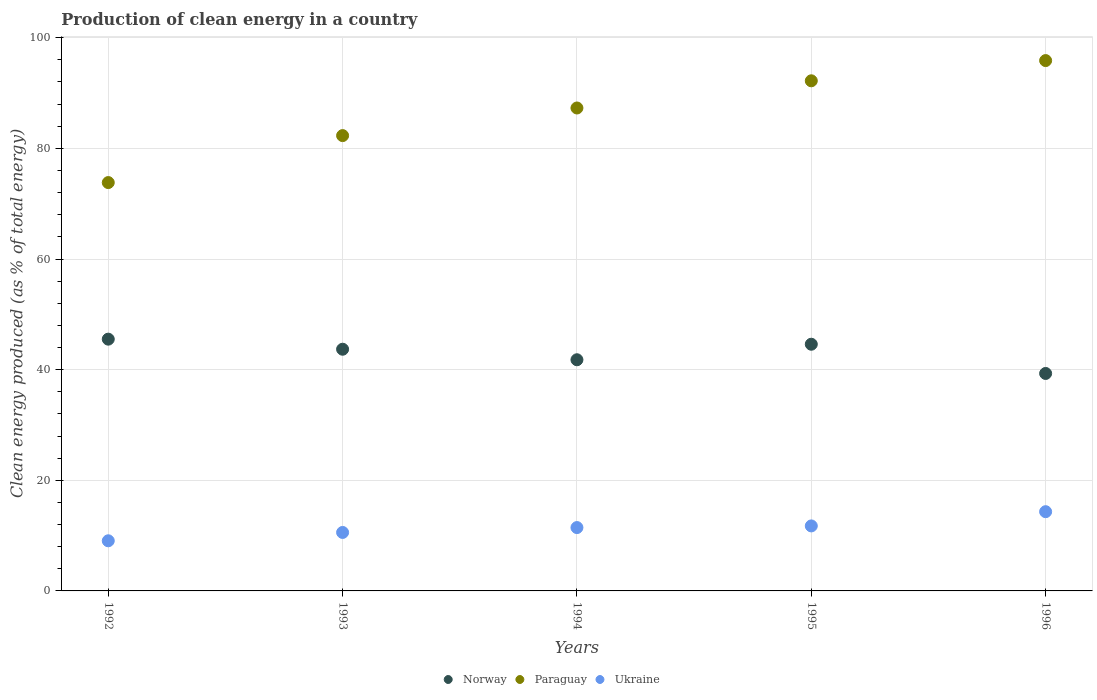What is the percentage of clean energy produced in Norway in 1994?
Give a very brief answer. 41.79. Across all years, what is the maximum percentage of clean energy produced in Paraguay?
Ensure brevity in your answer.  95.87. Across all years, what is the minimum percentage of clean energy produced in Paraguay?
Make the answer very short. 73.82. In which year was the percentage of clean energy produced in Norway minimum?
Provide a short and direct response. 1996. What is the total percentage of clean energy produced in Norway in the graph?
Your response must be concise. 214.89. What is the difference between the percentage of clean energy produced in Ukraine in 1993 and that in 1996?
Your answer should be very brief. -3.75. What is the difference between the percentage of clean energy produced in Paraguay in 1993 and the percentage of clean energy produced in Ukraine in 1994?
Give a very brief answer. 70.85. What is the average percentage of clean energy produced in Ukraine per year?
Make the answer very short. 11.43. In the year 1993, what is the difference between the percentage of clean energy produced in Paraguay and percentage of clean energy produced in Ukraine?
Provide a short and direct response. 71.74. In how many years, is the percentage of clean energy produced in Ukraine greater than 60 %?
Ensure brevity in your answer.  0. What is the ratio of the percentage of clean energy produced in Paraguay in 1993 to that in 1996?
Give a very brief answer. 0.86. What is the difference between the highest and the second highest percentage of clean energy produced in Norway?
Make the answer very short. 0.92. What is the difference between the highest and the lowest percentage of clean energy produced in Ukraine?
Give a very brief answer. 5.26. In how many years, is the percentage of clean energy produced in Norway greater than the average percentage of clean energy produced in Norway taken over all years?
Offer a very short reply. 3. Is the sum of the percentage of clean energy produced in Paraguay in 1994 and 1995 greater than the maximum percentage of clean energy produced in Ukraine across all years?
Ensure brevity in your answer.  Yes. Does the percentage of clean energy produced in Paraguay monotonically increase over the years?
Ensure brevity in your answer.  Yes. Is the percentage of clean energy produced in Ukraine strictly greater than the percentage of clean energy produced in Norway over the years?
Provide a succinct answer. No. How many dotlines are there?
Your answer should be compact. 3. How many years are there in the graph?
Keep it short and to the point. 5. What is the difference between two consecutive major ticks on the Y-axis?
Your answer should be compact. 20. Does the graph contain any zero values?
Your answer should be very brief. No. Where does the legend appear in the graph?
Offer a very short reply. Bottom center. How many legend labels are there?
Offer a very short reply. 3. What is the title of the graph?
Your response must be concise. Production of clean energy in a country. What is the label or title of the Y-axis?
Your answer should be very brief. Clean energy produced (as % of total energy). What is the Clean energy produced (as % of total energy) of Norway in 1992?
Provide a succinct answer. 45.51. What is the Clean energy produced (as % of total energy) in Paraguay in 1992?
Keep it short and to the point. 73.82. What is the Clean energy produced (as % of total energy) of Ukraine in 1992?
Your response must be concise. 9.06. What is the Clean energy produced (as % of total energy) in Norway in 1993?
Make the answer very short. 43.69. What is the Clean energy produced (as % of total energy) in Paraguay in 1993?
Keep it short and to the point. 82.31. What is the Clean energy produced (as % of total energy) of Ukraine in 1993?
Your answer should be compact. 10.57. What is the Clean energy produced (as % of total energy) of Norway in 1994?
Provide a succinct answer. 41.79. What is the Clean energy produced (as % of total energy) in Paraguay in 1994?
Provide a succinct answer. 87.3. What is the Clean energy produced (as % of total energy) in Ukraine in 1994?
Your answer should be compact. 11.45. What is the Clean energy produced (as % of total energy) of Norway in 1995?
Make the answer very short. 44.59. What is the Clean energy produced (as % of total energy) in Paraguay in 1995?
Ensure brevity in your answer.  92.21. What is the Clean energy produced (as % of total energy) of Ukraine in 1995?
Offer a very short reply. 11.75. What is the Clean energy produced (as % of total energy) in Norway in 1996?
Provide a short and direct response. 39.31. What is the Clean energy produced (as % of total energy) in Paraguay in 1996?
Your response must be concise. 95.87. What is the Clean energy produced (as % of total energy) of Ukraine in 1996?
Make the answer very short. 14.32. Across all years, what is the maximum Clean energy produced (as % of total energy) in Norway?
Make the answer very short. 45.51. Across all years, what is the maximum Clean energy produced (as % of total energy) in Paraguay?
Provide a succinct answer. 95.87. Across all years, what is the maximum Clean energy produced (as % of total energy) in Ukraine?
Your response must be concise. 14.32. Across all years, what is the minimum Clean energy produced (as % of total energy) of Norway?
Your response must be concise. 39.31. Across all years, what is the minimum Clean energy produced (as % of total energy) of Paraguay?
Make the answer very short. 73.82. Across all years, what is the minimum Clean energy produced (as % of total energy) of Ukraine?
Offer a terse response. 9.06. What is the total Clean energy produced (as % of total energy) of Norway in the graph?
Provide a succinct answer. 214.89. What is the total Clean energy produced (as % of total energy) in Paraguay in the graph?
Your answer should be very brief. 431.5. What is the total Clean energy produced (as % of total energy) in Ukraine in the graph?
Your response must be concise. 57.16. What is the difference between the Clean energy produced (as % of total energy) of Norway in 1992 and that in 1993?
Make the answer very short. 1.82. What is the difference between the Clean energy produced (as % of total energy) in Paraguay in 1992 and that in 1993?
Make the answer very short. -8.49. What is the difference between the Clean energy produced (as % of total energy) of Ukraine in 1992 and that in 1993?
Give a very brief answer. -1.51. What is the difference between the Clean energy produced (as % of total energy) of Norway in 1992 and that in 1994?
Offer a very short reply. 3.72. What is the difference between the Clean energy produced (as % of total energy) in Paraguay in 1992 and that in 1994?
Provide a short and direct response. -13.48. What is the difference between the Clean energy produced (as % of total energy) of Ukraine in 1992 and that in 1994?
Ensure brevity in your answer.  -2.39. What is the difference between the Clean energy produced (as % of total energy) in Norway in 1992 and that in 1995?
Offer a terse response. 0.92. What is the difference between the Clean energy produced (as % of total energy) of Paraguay in 1992 and that in 1995?
Offer a very short reply. -18.4. What is the difference between the Clean energy produced (as % of total energy) of Ukraine in 1992 and that in 1995?
Ensure brevity in your answer.  -2.69. What is the difference between the Clean energy produced (as % of total energy) in Norway in 1992 and that in 1996?
Your answer should be very brief. 6.2. What is the difference between the Clean energy produced (as % of total energy) in Paraguay in 1992 and that in 1996?
Keep it short and to the point. -22.05. What is the difference between the Clean energy produced (as % of total energy) in Ukraine in 1992 and that in 1996?
Provide a short and direct response. -5.26. What is the difference between the Clean energy produced (as % of total energy) of Norway in 1993 and that in 1994?
Provide a succinct answer. 1.9. What is the difference between the Clean energy produced (as % of total energy) of Paraguay in 1993 and that in 1994?
Your response must be concise. -4.99. What is the difference between the Clean energy produced (as % of total energy) in Ukraine in 1993 and that in 1994?
Your response must be concise. -0.88. What is the difference between the Clean energy produced (as % of total energy) in Norway in 1993 and that in 1995?
Your response must be concise. -0.9. What is the difference between the Clean energy produced (as % of total energy) of Paraguay in 1993 and that in 1995?
Provide a short and direct response. -9.91. What is the difference between the Clean energy produced (as % of total energy) of Ukraine in 1993 and that in 1995?
Ensure brevity in your answer.  -1.18. What is the difference between the Clean energy produced (as % of total energy) of Norway in 1993 and that in 1996?
Provide a short and direct response. 4.38. What is the difference between the Clean energy produced (as % of total energy) in Paraguay in 1993 and that in 1996?
Keep it short and to the point. -13.56. What is the difference between the Clean energy produced (as % of total energy) of Ukraine in 1993 and that in 1996?
Ensure brevity in your answer.  -3.75. What is the difference between the Clean energy produced (as % of total energy) of Norway in 1994 and that in 1995?
Ensure brevity in your answer.  -2.81. What is the difference between the Clean energy produced (as % of total energy) of Paraguay in 1994 and that in 1995?
Offer a terse response. -4.91. What is the difference between the Clean energy produced (as % of total energy) of Ukraine in 1994 and that in 1995?
Offer a very short reply. -0.3. What is the difference between the Clean energy produced (as % of total energy) in Norway in 1994 and that in 1996?
Your answer should be very brief. 2.48. What is the difference between the Clean energy produced (as % of total energy) in Paraguay in 1994 and that in 1996?
Ensure brevity in your answer.  -8.57. What is the difference between the Clean energy produced (as % of total energy) of Ukraine in 1994 and that in 1996?
Provide a succinct answer. -2.87. What is the difference between the Clean energy produced (as % of total energy) of Norway in 1995 and that in 1996?
Your answer should be very brief. 5.28. What is the difference between the Clean energy produced (as % of total energy) in Paraguay in 1995 and that in 1996?
Provide a short and direct response. -3.65. What is the difference between the Clean energy produced (as % of total energy) of Ukraine in 1995 and that in 1996?
Your answer should be compact. -2.57. What is the difference between the Clean energy produced (as % of total energy) in Norway in 1992 and the Clean energy produced (as % of total energy) in Paraguay in 1993?
Offer a terse response. -36.8. What is the difference between the Clean energy produced (as % of total energy) in Norway in 1992 and the Clean energy produced (as % of total energy) in Ukraine in 1993?
Give a very brief answer. 34.94. What is the difference between the Clean energy produced (as % of total energy) of Paraguay in 1992 and the Clean energy produced (as % of total energy) of Ukraine in 1993?
Offer a very short reply. 63.25. What is the difference between the Clean energy produced (as % of total energy) of Norway in 1992 and the Clean energy produced (as % of total energy) of Paraguay in 1994?
Ensure brevity in your answer.  -41.79. What is the difference between the Clean energy produced (as % of total energy) in Norway in 1992 and the Clean energy produced (as % of total energy) in Ukraine in 1994?
Offer a very short reply. 34.06. What is the difference between the Clean energy produced (as % of total energy) in Paraguay in 1992 and the Clean energy produced (as % of total energy) in Ukraine in 1994?
Your response must be concise. 62.36. What is the difference between the Clean energy produced (as % of total energy) of Norway in 1992 and the Clean energy produced (as % of total energy) of Paraguay in 1995?
Keep it short and to the point. -46.7. What is the difference between the Clean energy produced (as % of total energy) in Norway in 1992 and the Clean energy produced (as % of total energy) in Ukraine in 1995?
Offer a terse response. 33.76. What is the difference between the Clean energy produced (as % of total energy) of Paraguay in 1992 and the Clean energy produced (as % of total energy) of Ukraine in 1995?
Provide a short and direct response. 62.07. What is the difference between the Clean energy produced (as % of total energy) of Norway in 1992 and the Clean energy produced (as % of total energy) of Paraguay in 1996?
Offer a terse response. -50.36. What is the difference between the Clean energy produced (as % of total energy) of Norway in 1992 and the Clean energy produced (as % of total energy) of Ukraine in 1996?
Keep it short and to the point. 31.19. What is the difference between the Clean energy produced (as % of total energy) of Paraguay in 1992 and the Clean energy produced (as % of total energy) of Ukraine in 1996?
Keep it short and to the point. 59.49. What is the difference between the Clean energy produced (as % of total energy) of Norway in 1993 and the Clean energy produced (as % of total energy) of Paraguay in 1994?
Provide a short and direct response. -43.61. What is the difference between the Clean energy produced (as % of total energy) in Norway in 1993 and the Clean energy produced (as % of total energy) in Ukraine in 1994?
Offer a terse response. 32.24. What is the difference between the Clean energy produced (as % of total energy) of Paraguay in 1993 and the Clean energy produced (as % of total energy) of Ukraine in 1994?
Ensure brevity in your answer.  70.85. What is the difference between the Clean energy produced (as % of total energy) in Norway in 1993 and the Clean energy produced (as % of total energy) in Paraguay in 1995?
Your response must be concise. -48.52. What is the difference between the Clean energy produced (as % of total energy) in Norway in 1993 and the Clean energy produced (as % of total energy) in Ukraine in 1995?
Your answer should be very brief. 31.94. What is the difference between the Clean energy produced (as % of total energy) in Paraguay in 1993 and the Clean energy produced (as % of total energy) in Ukraine in 1995?
Give a very brief answer. 70.56. What is the difference between the Clean energy produced (as % of total energy) in Norway in 1993 and the Clean energy produced (as % of total energy) in Paraguay in 1996?
Your answer should be compact. -52.18. What is the difference between the Clean energy produced (as % of total energy) of Norway in 1993 and the Clean energy produced (as % of total energy) of Ukraine in 1996?
Provide a succinct answer. 29.37. What is the difference between the Clean energy produced (as % of total energy) in Paraguay in 1993 and the Clean energy produced (as % of total energy) in Ukraine in 1996?
Your response must be concise. 67.98. What is the difference between the Clean energy produced (as % of total energy) of Norway in 1994 and the Clean energy produced (as % of total energy) of Paraguay in 1995?
Offer a very short reply. -50.43. What is the difference between the Clean energy produced (as % of total energy) in Norway in 1994 and the Clean energy produced (as % of total energy) in Ukraine in 1995?
Provide a succinct answer. 30.04. What is the difference between the Clean energy produced (as % of total energy) of Paraguay in 1994 and the Clean energy produced (as % of total energy) of Ukraine in 1995?
Your answer should be compact. 75.55. What is the difference between the Clean energy produced (as % of total energy) of Norway in 1994 and the Clean energy produced (as % of total energy) of Paraguay in 1996?
Your answer should be very brief. -54.08. What is the difference between the Clean energy produced (as % of total energy) of Norway in 1994 and the Clean energy produced (as % of total energy) of Ukraine in 1996?
Provide a succinct answer. 27.46. What is the difference between the Clean energy produced (as % of total energy) in Paraguay in 1994 and the Clean energy produced (as % of total energy) in Ukraine in 1996?
Offer a very short reply. 72.98. What is the difference between the Clean energy produced (as % of total energy) of Norway in 1995 and the Clean energy produced (as % of total energy) of Paraguay in 1996?
Keep it short and to the point. -51.27. What is the difference between the Clean energy produced (as % of total energy) of Norway in 1995 and the Clean energy produced (as % of total energy) of Ukraine in 1996?
Your answer should be very brief. 30.27. What is the difference between the Clean energy produced (as % of total energy) of Paraguay in 1995 and the Clean energy produced (as % of total energy) of Ukraine in 1996?
Give a very brief answer. 77.89. What is the average Clean energy produced (as % of total energy) of Norway per year?
Offer a very short reply. 42.98. What is the average Clean energy produced (as % of total energy) of Paraguay per year?
Make the answer very short. 86.3. What is the average Clean energy produced (as % of total energy) of Ukraine per year?
Make the answer very short. 11.43. In the year 1992, what is the difference between the Clean energy produced (as % of total energy) of Norway and Clean energy produced (as % of total energy) of Paraguay?
Ensure brevity in your answer.  -28.31. In the year 1992, what is the difference between the Clean energy produced (as % of total energy) in Norway and Clean energy produced (as % of total energy) in Ukraine?
Give a very brief answer. 36.45. In the year 1992, what is the difference between the Clean energy produced (as % of total energy) in Paraguay and Clean energy produced (as % of total energy) in Ukraine?
Your response must be concise. 64.75. In the year 1993, what is the difference between the Clean energy produced (as % of total energy) of Norway and Clean energy produced (as % of total energy) of Paraguay?
Your answer should be very brief. -38.62. In the year 1993, what is the difference between the Clean energy produced (as % of total energy) of Norway and Clean energy produced (as % of total energy) of Ukraine?
Provide a short and direct response. 33.12. In the year 1993, what is the difference between the Clean energy produced (as % of total energy) of Paraguay and Clean energy produced (as % of total energy) of Ukraine?
Give a very brief answer. 71.74. In the year 1994, what is the difference between the Clean energy produced (as % of total energy) of Norway and Clean energy produced (as % of total energy) of Paraguay?
Offer a very short reply. -45.51. In the year 1994, what is the difference between the Clean energy produced (as % of total energy) of Norway and Clean energy produced (as % of total energy) of Ukraine?
Your answer should be very brief. 30.34. In the year 1994, what is the difference between the Clean energy produced (as % of total energy) of Paraguay and Clean energy produced (as % of total energy) of Ukraine?
Make the answer very short. 75.85. In the year 1995, what is the difference between the Clean energy produced (as % of total energy) of Norway and Clean energy produced (as % of total energy) of Paraguay?
Ensure brevity in your answer.  -47.62. In the year 1995, what is the difference between the Clean energy produced (as % of total energy) of Norway and Clean energy produced (as % of total energy) of Ukraine?
Your answer should be compact. 32.84. In the year 1995, what is the difference between the Clean energy produced (as % of total energy) of Paraguay and Clean energy produced (as % of total energy) of Ukraine?
Your response must be concise. 80.46. In the year 1996, what is the difference between the Clean energy produced (as % of total energy) of Norway and Clean energy produced (as % of total energy) of Paraguay?
Offer a very short reply. -56.56. In the year 1996, what is the difference between the Clean energy produced (as % of total energy) of Norway and Clean energy produced (as % of total energy) of Ukraine?
Provide a short and direct response. 24.99. In the year 1996, what is the difference between the Clean energy produced (as % of total energy) in Paraguay and Clean energy produced (as % of total energy) in Ukraine?
Keep it short and to the point. 81.54. What is the ratio of the Clean energy produced (as % of total energy) of Norway in 1992 to that in 1993?
Give a very brief answer. 1.04. What is the ratio of the Clean energy produced (as % of total energy) of Paraguay in 1992 to that in 1993?
Your answer should be very brief. 0.9. What is the ratio of the Clean energy produced (as % of total energy) of Ukraine in 1992 to that in 1993?
Offer a very short reply. 0.86. What is the ratio of the Clean energy produced (as % of total energy) of Norway in 1992 to that in 1994?
Provide a short and direct response. 1.09. What is the ratio of the Clean energy produced (as % of total energy) in Paraguay in 1992 to that in 1994?
Make the answer very short. 0.85. What is the ratio of the Clean energy produced (as % of total energy) in Ukraine in 1992 to that in 1994?
Your response must be concise. 0.79. What is the ratio of the Clean energy produced (as % of total energy) of Norway in 1992 to that in 1995?
Provide a succinct answer. 1.02. What is the ratio of the Clean energy produced (as % of total energy) in Paraguay in 1992 to that in 1995?
Your response must be concise. 0.8. What is the ratio of the Clean energy produced (as % of total energy) of Ukraine in 1992 to that in 1995?
Your answer should be very brief. 0.77. What is the ratio of the Clean energy produced (as % of total energy) in Norway in 1992 to that in 1996?
Your answer should be very brief. 1.16. What is the ratio of the Clean energy produced (as % of total energy) in Paraguay in 1992 to that in 1996?
Your answer should be compact. 0.77. What is the ratio of the Clean energy produced (as % of total energy) of Ukraine in 1992 to that in 1996?
Your response must be concise. 0.63. What is the ratio of the Clean energy produced (as % of total energy) in Norway in 1993 to that in 1994?
Keep it short and to the point. 1.05. What is the ratio of the Clean energy produced (as % of total energy) of Paraguay in 1993 to that in 1994?
Your answer should be very brief. 0.94. What is the ratio of the Clean energy produced (as % of total energy) in Ukraine in 1993 to that in 1994?
Provide a succinct answer. 0.92. What is the ratio of the Clean energy produced (as % of total energy) of Norway in 1993 to that in 1995?
Keep it short and to the point. 0.98. What is the ratio of the Clean energy produced (as % of total energy) of Paraguay in 1993 to that in 1995?
Your answer should be compact. 0.89. What is the ratio of the Clean energy produced (as % of total energy) of Ukraine in 1993 to that in 1995?
Make the answer very short. 0.9. What is the ratio of the Clean energy produced (as % of total energy) in Norway in 1993 to that in 1996?
Ensure brevity in your answer.  1.11. What is the ratio of the Clean energy produced (as % of total energy) of Paraguay in 1993 to that in 1996?
Provide a succinct answer. 0.86. What is the ratio of the Clean energy produced (as % of total energy) in Ukraine in 1993 to that in 1996?
Give a very brief answer. 0.74. What is the ratio of the Clean energy produced (as % of total energy) in Norway in 1994 to that in 1995?
Give a very brief answer. 0.94. What is the ratio of the Clean energy produced (as % of total energy) in Paraguay in 1994 to that in 1995?
Your answer should be compact. 0.95. What is the ratio of the Clean energy produced (as % of total energy) in Ukraine in 1994 to that in 1995?
Your answer should be very brief. 0.97. What is the ratio of the Clean energy produced (as % of total energy) in Norway in 1994 to that in 1996?
Keep it short and to the point. 1.06. What is the ratio of the Clean energy produced (as % of total energy) in Paraguay in 1994 to that in 1996?
Your answer should be compact. 0.91. What is the ratio of the Clean energy produced (as % of total energy) of Ukraine in 1994 to that in 1996?
Offer a terse response. 0.8. What is the ratio of the Clean energy produced (as % of total energy) in Norway in 1995 to that in 1996?
Your answer should be compact. 1.13. What is the ratio of the Clean energy produced (as % of total energy) of Paraguay in 1995 to that in 1996?
Your response must be concise. 0.96. What is the ratio of the Clean energy produced (as % of total energy) of Ukraine in 1995 to that in 1996?
Provide a succinct answer. 0.82. What is the difference between the highest and the second highest Clean energy produced (as % of total energy) of Norway?
Your response must be concise. 0.92. What is the difference between the highest and the second highest Clean energy produced (as % of total energy) in Paraguay?
Provide a succinct answer. 3.65. What is the difference between the highest and the second highest Clean energy produced (as % of total energy) in Ukraine?
Make the answer very short. 2.57. What is the difference between the highest and the lowest Clean energy produced (as % of total energy) in Norway?
Offer a very short reply. 6.2. What is the difference between the highest and the lowest Clean energy produced (as % of total energy) in Paraguay?
Make the answer very short. 22.05. What is the difference between the highest and the lowest Clean energy produced (as % of total energy) of Ukraine?
Your answer should be compact. 5.26. 